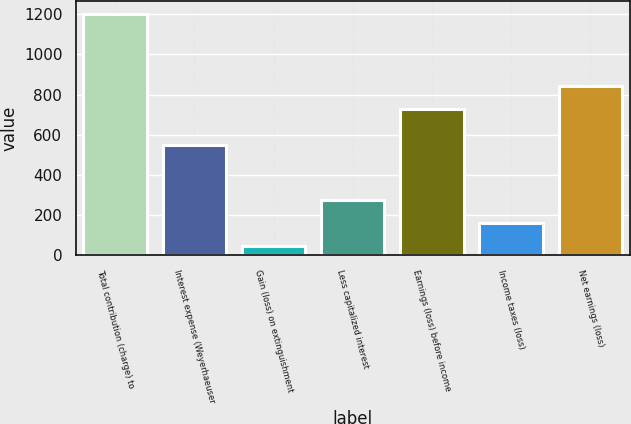<chart> <loc_0><loc_0><loc_500><loc_500><bar_chart><fcel>Total contribution (charge) to<fcel>Interest expense (Weyerhaeuser<fcel>Gain (loss) on extinguishment<fcel>Less capitalized interest<fcel>Earnings (loss) before income<fcel>Income taxes (loss)<fcel>Net earnings (loss)<nl><fcel>1203<fcel>547<fcel>45<fcel>276.6<fcel>729<fcel>160.8<fcel>844.8<nl></chart> 